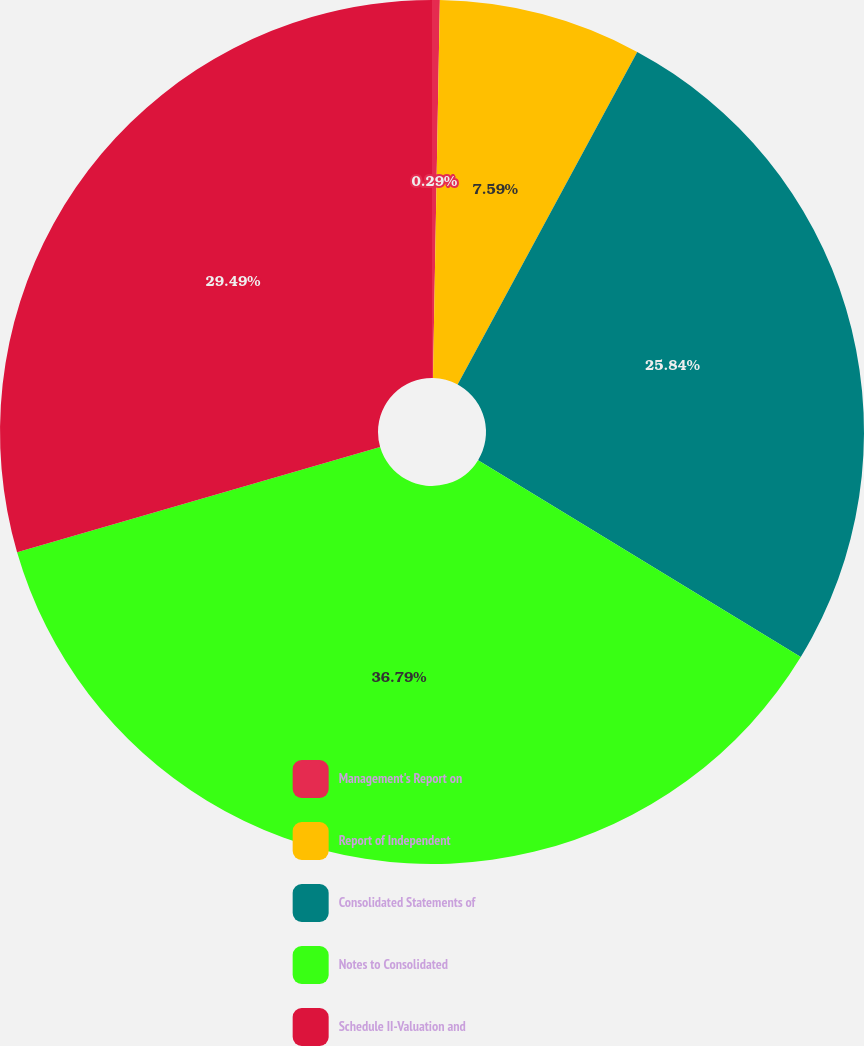<chart> <loc_0><loc_0><loc_500><loc_500><pie_chart><fcel>Management's Report on<fcel>Report of Independent<fcel>Consolidated Statements of<fcel>Notes to Consolidated<fcel>Schedule II-Valuation and<nl><fcel>0.29%<fcel>7.59%<fcel>25.84%<fcel>36.79%<fcel>29.49%<nl></chart> 